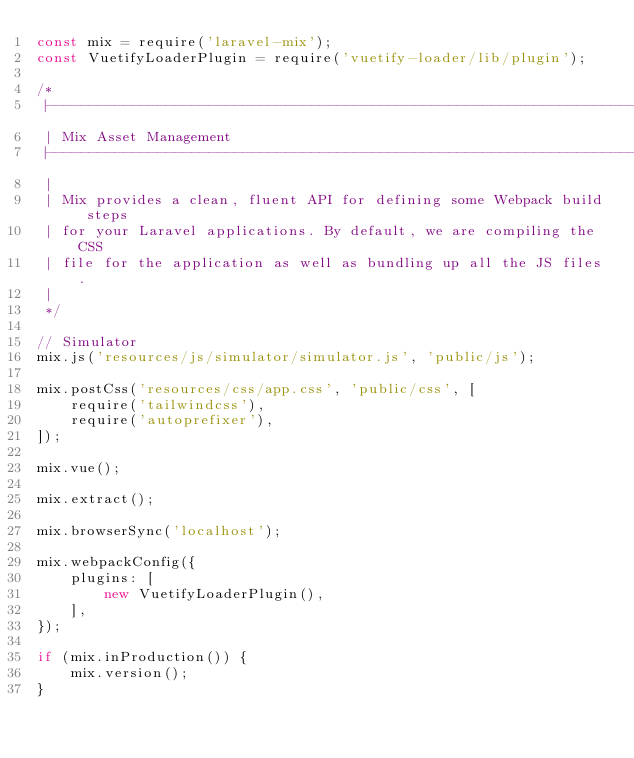<code> <loc_0><loc_0><loc_500><loc_500><_JavaScript_>const mix = require('laravel-mix');
const VuetifyLoaderPlugin = require('vuetify-loader/lib/plugin');

/*
 |--------------------------------------------------------------------------
 | Mix Asset Management
 |--------------------------------------------------------------------------
 |
 | Mix provides a clean, fluent API for defining some Webpack build steps
 | for your Laravel applications. By default, we are compiling the CSS
 | file for the application as well as bundling up all the JS files.
 |
 */

// Simulator
mix.js('resources/js/simulator/simulator.js', 'public/js');

mix.postCss('resources/css/app.css', 'public/css', [
    require('tailwindcss'),
    require('autoprefixer'),
]);

mix.vue();

mix.extract();

mix.browserSync('localhost');

mix.webpackConfig({
    plugins: [
        new VuetifyLoaderPlugin(),
    ],
});

if (mix.inProduction()) {
    mix.version();
}
</code> 